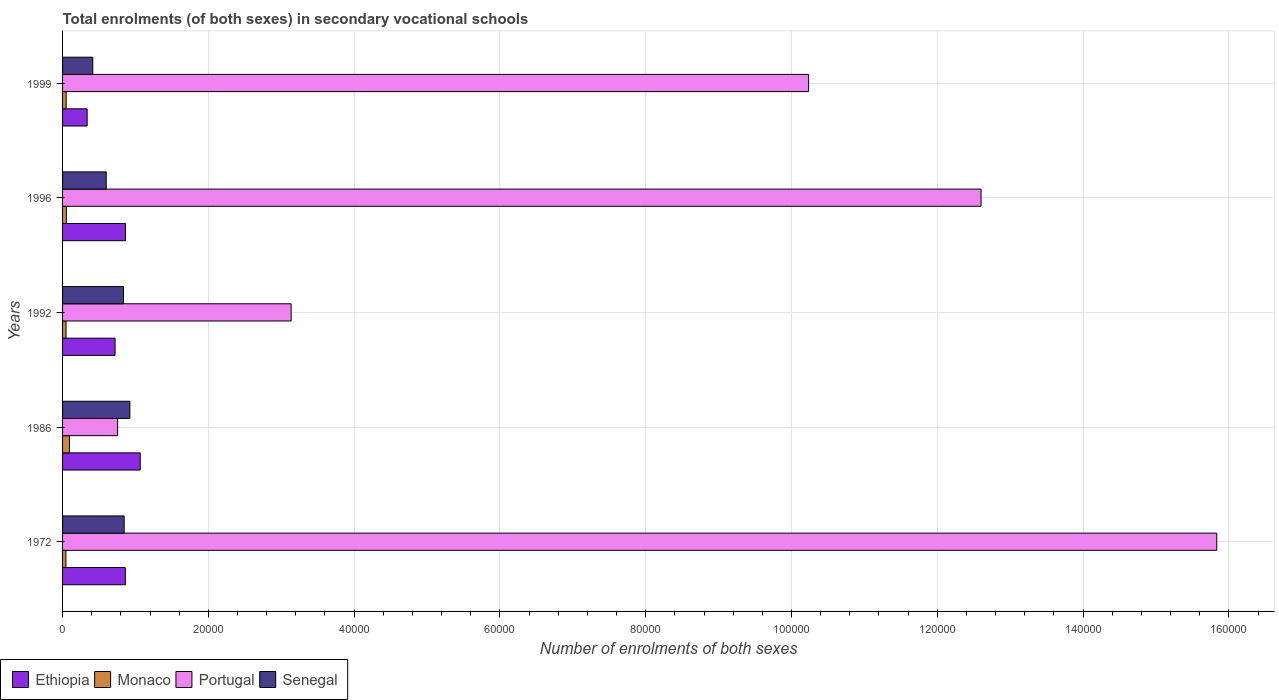How many groups of bars are there?
Your response must be concise. 5. Are the number of bars per tick equal to the number of legend labels?
Give a very brief answer. Yes. Are the number of bars on each tick of the Y-axis equal?
Keep it short and to the point. Yes. How many bars are there on the 2nd tick from the top?
Offer a very short reply. 4. What is the label of the 5th group of bars from the top?
Ensure brevity in your answer.  1972. What is the number of enrolments in secondary schools in Ethiopia in 1972?
Your response must be concise. 8612. Across all years, what is the maximum number of enrolments in secondary schools in Ethiopia?
Provide a succinct answer. 1.07e+04. Across all years, what is the minimum number of enrolments in secondary schools in Senegal?
Your answer should be compact. 4146. In which year was the number of enrolments in secondary schools in Monaco maximum?
Your response must be concise. 1986. In which year was the number of enrolments in secondary schools in Ethiopia minimum?
Ensure brevity in your answer.  1999. What is the total number of enrolments in secondary schools in Monaco in the graph?
Provide a succinct answer. 2899. What is the difference between the number of enrolments in secondary schools in Portugal in 1972 and that in 1992?
Your answer should be very brief. 1.27e+05. What is the difference between the number of enrolments in secondary schools in Portugal in 1992 and the number of enrolments in secondary schools in Monaco in 1972?
Make the answer very short. 3.09e+04. What is the average number of enrolments in secondary schools in Monaco per year?
Give a very brief answer. 579.8. In the year 1992, what is the difference between the number of enrolments in secondary schools in Senegal and number of enrolments in secondary schools in Monaco?
Your response must be concise. 7885. In how many years, is the number of enrolments in secondary schools in Monaco greater than 12000 ?
Offer a terse response. 0. What is the ratio of the number of enrolments in secondary schools in Ethiopia in 1972 to that in 1999?
Your response must be concise. 2.55. Is the number of enrolments in secondary schools in Monaco in 1996 less than that in 1999?
Offer a very short reply. No. What is the difference between the highest and the second highest number of enrolments in secondary schools in Ethiopia?
Your answer should be very brief. 2014. What is the difference between the highest and the lowest number of enrolments in secondary schools in Monaco?
Ensure brevity in your answer.  492. In how many years, is the number of enrolments in secondary schools in Senegal greater than the average number of enrolments in secondary schools in Senegal taken over all years?
Give a very brief answer. 3. What does the 1st bar from the top in 1999 represents?
Provide a succinct answer. Senegal. Is it the case that in every year, the sum of the number of enrolments in secondary schools in Portugal and number of enrolments in secondary schools in Monaco is greater than the number of enrolments in secondary schools in Ethiopia?
Your response must be concise. No. Are all the bars in the graph horizontal?
Make the answer very short. Yes. Does the graph contain any zero values?
Give a very brief answer. No. How many legend labels are there?
Your answer should be compact. 4. How are the legend labels stacked?
Provide a short and direct response. Horizontal. What is the title of the graph?
Give a very brief answer. Total enrolments (of both sexes) in secondary vocational schools. What is the label or title of the X-axis?
Offer a terse response. Number of enrolments of both sexes. What is the Number of enrolments of both sexes in Ethiopia in 1972?
Your answer should be very brief. 8612. What is the Number of enrolments of both sexes in Monaco in 1972?
Provide a succinct answer. 458. What is the Number of enrolments of both sexes of Portugal in 1972?
Offer a very short reply. 1.58e+05. What is the Number of enrolments of both sexes of Senegal in 1972?
Your answer should be compact. 8449. What is the Number of enrolments of both sexes in Ethiopia in 1986?
Your answer should be very brief. 1.07e+04. What is the Number of enrolments of both sexes in Monaco in 1986?
Your answer should be very brief. 950. What is the Number of enrolments of both sexes in Portugal in 1986?
Your answer should be compact. 7551. What is the Number of enrolments of both sexes in Senegal in 1986?
Ensure brevity in your answer.  9234. What is the Number of enrolments of both sexes in Ethiopia in 1992?
Your response must be concise. 7201. What is the Number of enrolments of both sexes of Monaco in 1992?
Give a very brief answer. 475. What is the Number of enrolments of both sexes in Portugal in 1992?
Provide a short and direct response. 3.14e+04. What is the Number of enrolments of both sexes of Senegal in 1992?
Give a very brief answer. 8360. What is the Number of enrolments of both sexes in Ethiopia in 1996?
Your response must be concise. 8638. What is the Number of enrolments of both sexes in Monaco in 1996?
Provide a short and direct response. 520. What is the Number of enrolments of both sexes of Portugal in 1996?
Offer a very short reply. 1.26e+05. What is the Number of enrolments of both sexes of Senegal in 1996?
Offer a very short reply. 5989. What is the Number of enrolments of both sexes in Ethiopia in 1999?
Give a very brief answer. 3374. What is the Number of enrolments of both sexes in Monaco in 1999?
Offer a terse response. 496. What is the Number of enrolments of both sexes of Portugal in 1999?
Your response must be concise. 1.02e+05. What is the Number of enrolments of both sexes in Senegal in 1999?
Offer a very short reply. 4146. Across all years, what is the maximum Number of enrolments of both sexes of Ethiopia?
Make the answer very short. 1.07e+04. Across all years, what is the maximum Number of enrolments of both sexes in Monaco?
Make the answer very short. 950. Across all years, what is the maximum Number of enrolments of both sexes of Portugal?
Provide a short and direct response. 1.58e+05. Across all years, what is the maximum Number of enrolments of both sexes in Senegal?
Your answer should be very brief. 9234. Across all years, what is the minimum Number of enrolments of both sexes in Ethiopia?
Ensure brevity in your answer.  3374. Across all years, what is the minimum Number of enrolments of both sexes in Monaco?
Provide a short and direct response. 458. Across all years, what is the minimum Number of enrolments of both sexes in Portugal?
Ensure brevity in your answer.  7551. Across all years, what is the minimum Number of enrolments of both sexes of Senegal?
Give a very brief answer. 4146. What is the total Number of enrolments of both sexes of Ethiopia in the graph?
Offer a very short reply. 3.85e+04. What is the total Number of enrolments of both sexes in Monaco in the graph?
Your answer should be very brief. 2899. What is the total Number of enrolments of both sexes in Portugal in the graph?
Offer a terse response. 4.26e+05. What is the total Number of enrolments of both sexes in Senegal in the graph?
Offer a terse response. 3.62e+04. What is the difference between the Number of enrolments of both sexes of Ethiopia in 1972 and that in 1986?
Offer a very short reply. -2040. What is the difference between the Number of enrolments of both sexes in Monaco in 1972 and that in 1986?
Your response must be concise. -492. What is the difference between the Number of enrolments of both sexes of Portugal in 1972 and that in 1986?
Make the answer very short. 1.51e+05. What is the difference between the Number of enrolments of both sexes in Senegal in 1972 and that in 1986?
Ensure brevity in your answer.  -785. What is the difference between the Number of enrolments of both sexes in Ethiopia in 1972 and that in 1992?
Your answer should be very brief. 1411. What is the difference between the Number of enrolments of both sexes in Portugal in 1972 and that in 1992?
Your answer should be very brief. 1.27e+05. What is the difference between the Number of enrolments of both sexes in Senegal in 1972 and that in 1992?
Give a very brief answer. 89. What is the difference between the Number of enrolments of both sexes in Monaco in 1972 and that in 1996?
Make the answer very short. -62. What is the difference between the Number of enrolments of both sexes in Portugal in 1972 and that in 1996?
Give a very brief answer. 3.23e+04. What is the difference between the Number of enrolments of both sexes in Senegal in 1972 and that in 1996?
Make the answer very short. 2460. What is the difference between the Number of enrolments of both sexes in Ethiopia in 1972 and that in 1999?
Your answer should be compact. 5238. What is the difference between the Number of enrolments of both sexes in Monaco in 1972 and that in 1999?
Your answer should be compact. -38. What is the difference between the Number of enrolments of both sexes of Portugal in 1972 and that in 1999?
Give a very brief answer. 5.60e+04. What is the difference between the Number of enrolments of both sexes in Senegal in 1972 and that in 1999?
Keep it short and to the point. 4303. What is the difference between the Number of enrolments of both sexes in Ethiopia in 1986 and that in 1992?
Your answer should be very brief. 3451. What is the difference between the Number of enrolments of both sexes of Monaco in 1986 and that in 1992?
Offer a terse response. 475. What is the difference between the Number of enrolments of both sexes in Portugal in 1986 and that in 1992?
Offer a terse response. -2.38e+04. What is the difference between the Number of enrolments of both sexes of Senegal in 1986 and that in 1992?
Offer a terse response. 874. What is the difference between the Number of enrolments of both sexes of Ethiopia in 1986 and that in 1996?
Provide a short and direct response. 2014. What is the difference between the Number of enrolments of both sexes of Monaco in 1986 and that in 1996?
Your response must be concise. 430. What is the difference between the Number of enrolments of both sexes of Portugal in 1986 and that in 1996?
Provide a succinct answer. -1.18e+05. What is the difference between the Number of enrolments of both sexes of Senegal in 1986 and that in 1996?
Offer a very short reply. 3245. What is the difference between the Number of enrolments of both sexes of Ethiopia in 1986 and that in 1999?
Keep it short and to the point. 7278. What is the difference between the Number of enrolments of both sexes in Monaco in 1986 and that in 1999?
Offer a terse response. 454. What is the difference between the Number of enrolments of both sexes of Portugal in 1986 and that in 1999?
Provide a short and direct response. -9.48e+04. What is the difference between the Number of enrolments of both sexes of Senegal in 1986 and that in 1999?
Make the answer very short. 5088. What is the difference between the Number of enrolments of both sexes in Ethiopia in 1992 and that in 1996?
Offer a very short reply. -1437. What is the difference between the Number of enrolments of both sexes in Monaco in 1992 and that in 1996?
Offer a terse response. -45. What is the difference between the Number of enrolments of both sexes in Portugal in 1992 and that in 1996?
Offer a terse response. -9.46e+04. What is the difference between the Number of enrolments of both sexes of Senegal in 1992 and that in 1996?
Give a very brief answer. 2371. What is the difference between the Number of enrolments of both sexes in Ethiopia in 1992 and that in 1999?
Provide a short and direct response. 3827. What is the difference between the Number of enrolments of both sexes of Portugal in 1992 and that in 1999?
Offer a terse response. -7.10e+04. What is the difference between the Number of enrolments of both sexes in Senegal in 1992 and that in 1999?
Keep it short and to the point. 4214. What is the difference between the Number of enrolments of both sexes of Ethiopia in 1996 and that in 1999?
Your answer should be compact. 5264. What is the difference between the Number of enrolments of both sexes in Portugal in 1996 and that in 1999?
Keep it short and to the point. 2.37e+04. What is the difference between the Number of enrolments of both sexes in Senegal in 1996 and that in 1999?
Ensure brevity in your answer.  1843. What is the difference between the Number of enrolments of both sexes of Ethiopia in 1972 and the Number of enrolments of both sexes of Monaco in 1986?
Provide a succinct answer. 7662. What is the difference between the Number of enrolments of both sexes of Ethiopia in 1972 and the Number of enrolments of both sexes of Portugal in 1986?
Offer a very short reply. 1061. What is the difference between the Number of enrolments of both sexes in Ethiopia in 1972 and the Number of enrolments of both sexes in Senegal in 1986?
Offer a very short reply. -622. What is the difference between the Number of enrolments of both sexes in Monaco in 1972 and the Number of enrolments of both sexes in Portugal in 1986?
Keep it short and to the point. -7093. What is the difference between the Number of enrolments of both sexes of Monaco in 1972 and the Number of enrolments of both sexes of Senegal in 1986?
Keep it short and to the point. -8776. What is the difference between the Number of enrolments of both sexes of Portugal in 1972 and the Number of enrolments of both sexes of Senegal in 1986?
Your response must be concise. 1.49e+05. What is the difference between the Number of enrolments of both sexes in Ethiopia in 1972 and the Number of enrolments of both sexes in Monaco in 1992?
Offer a terse response. 8137. What is the difference between the Number of enrolments of both sexes of Ethiopia in 1972 and the Number of enrolments of both sexes of Portugal in 1992?
Keep it short and to the point. -2.27e+04. What is the difference between the Number of enrolments of both sexes of Ethiopia in 1972 and the Number of enrolments of both sexes of Senegal in 1992?
Offer a terse response. 252. What is the difference between the Number of enrolments of both sexes of Monaco in 1972 and the Number of enrolments of both sexes of Portugal in 1992?
Your response must be concise. -3.09e+04. What is the difference between the Number of enrolments of both sexes of Monaco in 1972 and the Number of enrolments of both sexes of Senegal in 1992?
Your answer should be compact. -7902. What is the difference between the Number of enrolments of both sexes of Portugal in 1972 and the Number of enrolments of both sexes of Senegal in 1992?
Offer a terse response. 1.50e+05. What is the difference between the Number of enrolments of both sexes of Ethiopia in 1972 and the Number of enrolments of both sexes of Monaco in 1996?
Provide a succinct answer. 8092. What is the difference between the Number of enrolments of both sexes in Ethiopia in 1972 and the Number of enrolments of both sexes in Portugal in 1996?
Ensure brevity in your answer.  -1.17e+05. What is the difference between the Number of enrolments of both sexes of Ethiopia in 1972 and the Number of enrolments of both sexes of Senegal in 1996?
Provide a short and direct response. 2623. What is the difference between the Number of enrolments of both sexes in Monaco in 1972 and the Number of enrolments of both sexes in Portugal in 1996?
Your answer should be very brief. -1.26e+05. What is the difference between the Number of enrolments of both sexes of Monaco in 1972 and the Number of enrolments of both sexes of Senegal in 1996?
Provide a short and direct response. -5531. What is the difference between the Number of enrolments of both sexes of Portugal in 1972 and the Number of enrolments of both sexes of Senegal in 1996?
Keep it short and to the point. 1.52e+05. What is the difference between the Number of enrolments of both sexes in Ethiopia in 1972 and the Number of enrolments of both sexes in Monaco in 1999?
Your response must be concise. 8116. What is the difference between the Number of enrolments of both sexes of Ethiopia in 1972 and the Number of enrolments of both sexes of Portugal in 1999?
Give a very brief answer. -9.37e+04. What is the difference between the Number of enrolments of both sexes of Ethiopia in 1972 and the Number of enrolments of both sexes of Senegal in 1999?
Provide a short and direct response. 4466. What is the difference between the Number of enrolments of both sexes of Monaco in 1972 and the Number of enrolments of both sexes of Portugal in 1999?
Your answer should be very brief. -1.02e+05. What is the difference between the Number of enrolments of both sexes of Monaco in 1972 and the Number of enrolments of both sexes of Senegal in 1999?
Offer a very short reply. -3688. What is the difference between the Number of enrolments of both sexes in Portugal in 1972 and the Number of enrolments of both sexes in Senegal in 1999?
Offer a terse response. 1.54e+05. What is the difference between the Number of enrolments of both sexes in Ethiopia in 1986 and the Number of enrolments of both sexes in Monaco in 1992?
Your answer should be compact. 1.02e+04. What is the difference between the Number of enrolments of both sexes in Ethiopia in 1986 and the Number of enrolments of both sexes in Portugal in 1992?
Offer a very short reply. -2.07e+04. What is the difference between the Number of enrolments of both sexes in Ethiopia in 1986 and the Number of enrolments of both sexes in Senegal in 1992?
Your answer should be very brief. 2292. What is the difference between the Number of enrolments of both sexes in Monaco in 1986 and the Number of enrolments of both sexes in Portugal in 1992?
Your response must be concise. -3.04e+04. What is the difference between the Number of enrolments of both sexes in Monaco in 1986 and the Number of enrolments of both sexes in Senegal in 1992?
Your answer should be very brief. -7410. What is the difference between the Number of enrolments of both sexes in Portugal in 1986 and the Number of enrolments of both sexes in Senegal in 1992?
Make the answer very short. -809. What is the difference between the Number of enrolments of both sexes in Ethiopia in 1986 and the Number of enrolments of both sexes in Monaco in 1996?
Keep it short and to the point. 1.01e+04. What is the difference between the Number of enrolments of both sexes in Ethiopia in 1986 and the Number of enrolments of both sexes in Portugal in 1996?
Keep it short and to the point. -1.15e+05. What is the difference between the Number of enrolments of both sexes in Ethiopia in 1986 and the Number of enrolments of both sexes in Senegal in 1996?
Ensure brevity in your answer.  4663. What is the difference between the Number of enrolments of both sexes of Monaco in 1986 and the Number of enrolments of both sexes of Portugal in 1996?
Ensure brevity in your answer.  -1.25e+05. What is the difference between the Number of enrolments of both sexes of Monaco in 1986 and the Number of enrolments of both sexes of Senegal in 1996?
Your response must be concise. -5039. What is the difference between the Number of enrolments of both sexes in Portugal in 1986 and the Number of enrolments of both sexes in Senegal in 1996?
Your response must be concise. 1562. What is the difference between the Number of enrolments of both sexes of Ethiopia in 1986 and the Number of enrolments of both sexes of Monaco in 1999?
Ensure brevity in your answer.  1.02e+04. What is the difference between the Number of enrolments of both sexes in Ethiopia in 1986 and the Number of enrolments of both sexes in Portugal in 1999?
Offer a very short reply. -9.17e+04. What is the difference between the Number of enrolments of both sexes in Ethiopia in 1986 and the Number of enrolments of both sexes in Senegal in 1999?
Your answer should be compact. 6506. What is the difference between the Number of enrolments of both sexes of Monaco in 1986 and the Number of enrolments of both sexes of Portugal in 1999?
Your answer should be compact. -1.01e+05. What is the difference between the Number of enrolments of both sexes of Monaco in 1986 and the Number of enrolments of both sexes of Senegal in 1999?
Your answer should be very brief. -3196. What is the difference between the Number of enrolments of both sexes in Portugal in 1986 and the Number of enrolments of both sexes in Senegal in 1999?
Offer a very short reply. 3405. What is the difference between the Number of enrolments of both sexes in Ethiopia in 1992 and the Number of enrolments of both sexes in Monaco in 1996?
Ensure brevity in your answer.  6681. What is the difference between the Number of enrolments of both sexes of Ethiopia in 1992 and the Number of enrolments of both sexes of Portugal in 1996?
Your answer should be very brief. -1.19e+05. What is the difference between the Number of enrolments of both sexes of Ethiopia in 1992 and the Number of enrolments of both sexes of Senegal in 1996?
Make the answer very short. 1212. What is the difference between the Number of enrolments of both sexes of Monaco in 1992 and the Number of enrolments of both sexes of Portugal in 1996?
Provide a short and direct response. -1.26e+05. What is the difference between the Number of enrolments of both sexes in Monaco in 1992 and the Number of enrolments of both sexes in Senegal in 1996?
Ensure brevity in your answer.  -5514. What is the difference between the Number of enrolments of both sexes of Portugal in 1992 and the Number of enrolments of both sexes of Senegal in 1996?
Provide a succinct answer. 2.54e+04. What is the difference between the Number of enrolments of both sexes in Ethiopia in 1992 and the Number of enrolments of both sexes in Monaco in 1999?
Provide a short and direct response. 6705. What is the difference between the Number of enrolments of both sexes in Ethiopia in 1992 and the Number of enrolments of both sexes in Portugal in 1999?
Your answer should be compact. -9.51e+04. What is the difference between the Number of enrolments of both sexes of Ethiopia in 1992 and the Number of enrolments of both sexes of Senegal in 1999?
Your answer should be compact. 3055. What is the difference between the Number of enrolments of both sexes of Monaco in 1992 and the Number of enrolments of both sexes of Portugal in 1999?
Ensure brevity in your answer.  -1.02e+05. What is the difference between the Number of enrolments of both sexes in Monaco in 1992 and the Number of enrolments of both sexes in Senegal in 1999?
Offer a very short reply. -3671. What is the difference between the Number of enrolments of both sexes of Portugal in 1992 and the Number of enrolments of both sexes of Senegal in 1999?
Your answer should be very brief. 2.72e+04. What is the difference between the Number of enrolments of both sexes of Ethiopia in 1996 and the Number of enrolments of both sexes of Monaco in 1999?
Make the answer very short. 8142. What is the difference between the Number of enrolments of both sexes of Ethiopia in 1996 and the Number of enrolments of both sexes of Portugal in 1999?
Make the answer very short. -9.37e+04. What is the difference between the Number of enrolments of both sexes of Ethiopia in 1996 and the Number of enrolments of both sexes of Senegal in 1999?
Make the answer very short. 4492. What is the difference between the Number of enrolments of both sexes of Monaco in 1996 and the Number of enrolments of both sexes of Portugal in 1999?
Ensure brevity in your answer.  -1.02e+05. What is the difference between the Number of enrolments of both sexes of Monaco in 1996 and the Number of enrolments of both sexes of Senegal in 1999?
Keep it short and to the point. -3626. What is the difference between the Number of enrolments of both sexes in Portugal in 1996 and the Number of enrolments of both sexes in Senegal in 1999?
Your response must be concise. 1.22e+05. What is the average Number of enrolments of both sexes of Ethiopia per year?
Provide a succinct answer. 7695.4. What is the average Number of enrolments of both sexes in Monaco per year?
Provide a short and direct response. 579.8. What is the average Number of enrolments of both sexes of Portugal per year?
Provide a succinct answer. 8.51e+04. What is the average Number of enrolments of both sexes in Senegal per year?
Your response must be concise. 7235.6. In the year 1972, what is the difference between the Number of enrolments of both sexes of Ethiopia and Number of enrolments of both sexes of Monaco?
Provide a succinct answer. 8154. In the year 1972, what is the difference between the Number of enrolments of both sexes in Ethiopia and Number of enrolments of both sexes in Portugal?
Your answer should be compact. -1.50e+05. In the year 1972, what is the difference between the Number of enrolments of both sexes in Ethiopia and Number of enrolments of both sexes in Senegal?
Your answer should be compact. 163. In the year 1972, what is the difference between the Number of enrolments of both sexes in Monaco and Number of enrolments of both sexes in Portugal?
Keep it short and to the point. -1.58e+05. In the year 1972, what is the difference between the Number of enrolments of both sexes in Monaco and Number of enrolments of both sexes in Senegal?
Offer a terse response. -7991. In the year 1972, what is the difference between the Number of enrolments of both sexes in Portugal and Number of enrolments of both sexes in Senegal?
Your answer should be very brief. 1.50e+05. In the year 1986, what is the difference between the Number of enrolments of both sexes in Ethiopia and Number of enrolments of both sexes in Monaco?
Offer a terse response. 9702. In the year 1986, what is the difference between the Number of enrolments of both sexes of Ethiopia and Number of enrolments of both sexes of Portugal?
Provide a short and direct response. 3101. In the year 1986, what is the difference between the Number of enrolments of both sexes in Ethiopia and Number of enrolments of both sexes in Senegal?
Make the answer very short. 1418. In the year 1986, what is the difference between the Number of enrolments of both sexes of Monaco and Number of enrolments of both sexes of Portugal?
Provide a succinct answer. -6601. In the year 1986, what is the difference between the Number of enrolments of both sexes in Monaco and Number of enrolments of both sexes in Senegal?
Your response must be concise. -8284. In the year 1986, what is the difference between the Number of enrolments of both sexes of Portugal and Number of enrolments of both sexes of Senegal?
Your response must be concise. -1683. In the year 1992, what is the difference between the Number of enrolments of both sexes of Ethiopia and Number of enrolments of both sexes of Monaco?
Your response must be concise. 6726. In the year 1992, what is the difference between the Number of enrolments of both sexes in Ethiopia and Number of enrolments of both sexes in Portugal?
Give a very brief answer. -2.42e+04. In the year 1992, what is the difference between the Number of enrolments of both sexes of Ethiopia and Number of enrolments of both sexes of Senegal?
Ensure brevity in your answer.  -1159. In the year 1992, what is the difference between the Number of enrolments of both sexes in Monaco and Number of enrolments of both sexes in Portugal?
Your answer should be very brief. -3.09e+04. In the year 1992, what is the difference between the Number of enrolments of both sexes in Monaco and Number of enrolments of both sexes in Senegal?
Your response must be concise. -7885. In the year 1992, what is the difference between the Number of enrolments of both sexes in Portugal and Number of enrolments of both sexes in Senegal?
Ensure brevity in your answer.  2.30e+04. In the year 1996, what is the difference between the Number of enrolments of both sexes in Ethiopia and Number of enrolments of both sexes in Monaco?
Your answer should be compact. 8118. In the year 1996, what is the difference between the Number of enrolments of both sexes of Ethiopia and Number of enrolments of both sexes of Portugal?
Provide a short and direct response. -1.17e+05. In the year 1996, what is the difference between the Number of enrolments of both sexes of Ethiopia and Number of enrolments of both sexes of Senegal?
Your response must be concise. 2649. In the year 1996, what is the difference between the Number of enrolments of both sexes in Monaco and Number of enrolments of both sexes in Portugal?
Keep it short and to the point. -1.25e+05. In the year 1996, what is the difference between the Number of enrolments of both sexes in Monaco and Number of enrolments of both sexes in Senegal?
Your answer should be very brief. -5469. In the year 1996, what is the difference between the Number of enrolments of both sexes of Portugal and Number of enrolments of both sexes of Senegal?
Make the answer very short. 1.20e+05. In the year 1999, what is the difference between the Number of enrolments of both sexes in Ethiopia and Number of enrolments of both sexes in Monaco?
Keep it short and to the point. 2878. In the year 1999, what is the difference between the Number of enrolments of both sexes of Ethiopia and Number of enrolments of both sexes of Portugal?
Offer a very short reply. -9.90e+04. In the year 1999, what is the difference between the Number of enrolments of both sexes in Ethiopia and Number of enrolments of both sexes in Senegal?
Offer a very short reply. -772. In the year 1999, what is the difference between the Number of enrolments of both sexes of Monaco and Number of enrolments of both sexes of Portugal?
Make the answer very short. -1.02e+05. In the year 1999, what is the difference between the Number of enrolments of both sexes in Monaco and Number of enrolments of both sexes in Senegal?
Provide a succinct answer. -3650. In the year 1999, what is the difference between the Number of enrolments of both sexes in Portugal and Number of enrolments of both sexes in Senegal?
Give a very brief answer. 9.82e+04. What is the ratio of the Number of enrolments of both sexes of Ethiopia in 1972 to that in 1986?
Your answer should be compact. 0.81. What is the ratio of the Number of enrolments of both sexes of Monaco in 1972 to that in 1986?
Your answer should be very brief. 0.48. What is the ratio of the Number of enrolments of both sexes in Portugal in 1972 to that in 1986?
Provide a succinct answer. 20.97. What is the ratio of the Number of enrolments of both sexes of Senegal in 1972 to that in 1986?
Your answer should be compact. 0.92. What is the ratio of the Number of enrolments of both sexes in Ethiopia in 1972 to that in 1992?
Provide a short and direct response. 1.2. What is the ratio of the Number of enrolments of both sexes in Monaco in 1972 to that in 1992?
Keep it short and to the point. 0.96. What is the ratio of the Number of enrolments of both sexes in Portugal in 1972 to that in 1992?
Provide a succinct answer. 5.05. What is the ratio of the Number of enrolments of both sexes of Senegal in 1972 to that in 1992?
Your answer should be compact. 1.01. What is the ratio of the Number of enrolments of both sexes in Ethiopia in 1972 to that in 1996?
Provide a short and direct response. 1. What is the ratio of the Number of enrolments of both sexes of Monaco in 1972 to that in 1996?
Your answer should be very brief. 0.88. What is the ratio of the Number of enrolments of both sexes in Portugal in 1972 to that in 1996?
Your response must be concise. 1.26. What is the ratio of the Number of enrolments of both sexes in Senegal in 1972 to that in 1996?
Keep it short and to the point. 1.41. What is the ratio of the Number of enrolments of both sexes in Ethiopia in 1972 to that in 1999?
Make the answer very short. 2.55. What is the ratio of the Number of enrolments of both sexes in Monaco in 1972 to that in 1999?
Make the answer very short. 0.92. What is the ratio of the Number of enrolments of both sexes of Portugal in 1972 to that in 1999?
Make the answer very short. 1.55. What is the ratio of the Number of enrolments of both sexes of Senegal in 1972 to that in 1999?
Offer a terse response. 2.04. What is the ratio of the Number of enrolments of both sexes of Ethiopia in 1986 to that in 1992?
Your answer should be compact. 1.48. What is the ratio of the Number of enrolments of both sexes in Monaco in 1986 to that in 1992?
Provide a succinct answer. 2. What is the ratio of the Number of enrolments of both sexes of Portugal in 1986 to that in 1992?
Keep it short and to the point. 0.24. What is the ratio of the Number of enrolments of both sexes of Senegal in 1986 to that in 1992?
Provide a short and direct response. 1.1. What is the ratio of the Number of enrolments of both sexes in Ethiopia in 1986 to that in 1996?
Your answer should be compact. 1.23. What is the ratio of the Number of enrolments of both sexes in Monaco in 1986 to that in 1996?
Your answer should be very brief. 1.83. What is the ratio of the Number of enrolments of both sexes of Portugal in 1986 to that in 1996?
Offer a very short reply. 0.06. What is the ratio of the Number of enrolments of both sexes of Senegal in 1986 to that in 1996?
Your answer should be compact. 1.54. What is the ratio of the Number of enrolments of both sexes of Ethiopia in 1986 to that in 1999?
Keep it short and to the point. 3.16. What is the ratio of the Number of enrolments of both sexes of Monaco in 1986 to that in 1999?
Your answer should be compact. 1.92. What is the ratio of the Number of enrolments of both sexes of Portugal in 1986 to that in 1999?
Make the answer very short. 0.07. What is the ratio of the Number of enrolments of both sexes of Senegal in 1986 to that in 1999?
Ensure brevity in your answer.  2.23. What is the ratio of the Number of enrolments of both sexes of Ethiopia in 1992 to that in 1996?
Make the answer very short. 0.83. What is the ratio of the Number of enrolments of both sexes in Monaco in 1992 to that in 1996?
Ensure brevity in your answer.  0.91. What is the ratio of the Number of enrolments of both sexes of Portugal in 1992 to that in 1996?
Give a very brief answer. 0.25. What is the ratio of the Number of enrolments of both sexes of Senegal in 1992 to that in 1996?
Provide a short and direct response. 1.4. What is the ratio of the Number of enrolments of both sexes in Ethiopia in 1992 to that in 1999?
Your answer should be compact. 2.13. What is the ratio of the Number of enrolments of both sexes of Monaco in 1992 to that in 1999?
Your answer should be very brief. 0.96. What is the ratio of the Number of enrolments of both sexes in Portugal in 1992 to that in 1999?
Make the answer very short. 0.31. What is the ratio of the Number of enrolments of both sexes of Senegal in 1992 to that in 1999?
Provide a succinct answer. 2.02. What is the ratio of the Number of enrolments of both sexes of Ethiopia in 1996 to that in 1999?
Make the answer very short. 2.56. What is the ratio of the Number of enrolments of both sexes of Monaco in 1996 to that in 1999?
Your answer should be compact. 1.05. What is the ratio of the Number of enrolments of both sexes of Portugal in 1996 to that in 1999?
Make the answer very short. 1.23. What is the ratio of the Number of enrolments of both sexes of Senegal in 1996 to that in 1999?
Offer a very short reply. 1.44. What is the difference between the highest and the second highest Number of enrolments of both sexes in Ethiopia?
Provide a succinct answer. 2014. What is the difference between the highest and the second highest Number of enrolments of both sexes in Monaco?
Make the answer very short. 430. What is the difference between the highest and the second highest Number of enrolments of both sexes in Portugal?
Your response must be concise. 3.23e+04. What is the difference between the highest and the second highest Number of enrolments of both sexes in Senegal?
Give a very brief answer. 785. What is the difference between the highest and the lowest Number of enrolments of both sexes of Ethiopia?
Offer a terse response. 7278. What is the difference between the highest and the lowest Number of enrolments of both sexes in Monaco?
Provide a succinct answer. 492. What is the difference between the highest and the lowest Number of enrolments of both sexes in Portugal?
Make the answer very short. 1.51e+05. What is the difference between the highest and the lowest Number of enrolments of both sexes in Senegal?
Provide a succinct answer. 5088. 